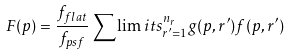<formula> <loc_0><loc_0><loc_500><loc_500>F ( p ) = \frac { f _ { f l a t } } { f _ { p s f } } \sum \lim i t s _ { r ^ { \prime } = 1 } ^ { n _ { r } } g ( p , r ^ { \prime } ) f ( p , r ^ { \prime } )</formula> 